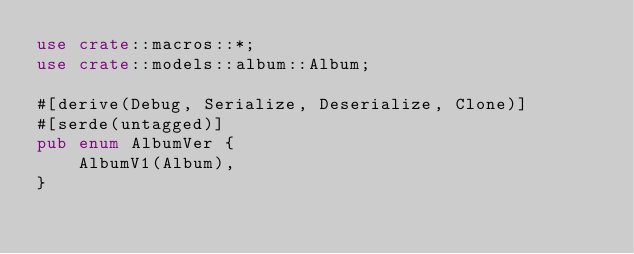Convert code to text. <code><loc_0><loc_0><loc_500><loc_500><_Rust_>use crate::macros::*;
use crate::models::album::Album;

#[derive(Debug, Serialize, Deserialize, Clone)]
#[serde(untagged)]
pub enum AlbumVer {
    AlbumV1(Album),
}
</code> 